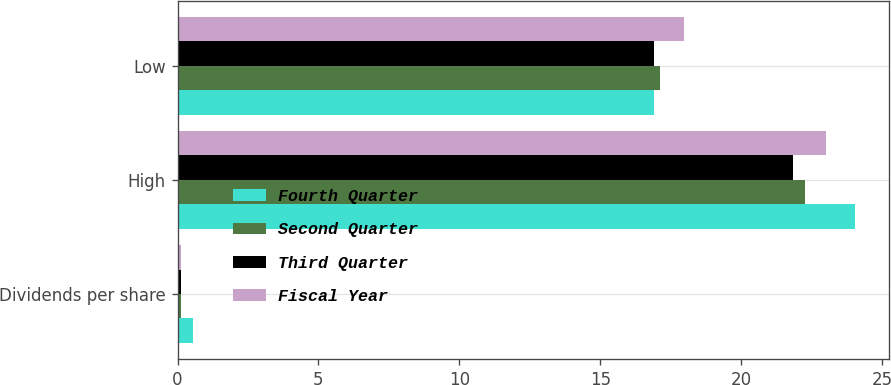<chart> <loc_0><loc_0><loc_500><loc_500><stacked_bar_chart><ecel><fcel>Dividends per share<fcel>High<fcel>Low<nl><fcel>Fourth Quarter<fcel>0.56<fcel>24.02<fcel>16.89<nl><fcel>Second Quarter<fcel>0.14<fcel>22.27<fcel>17.13<nl><fcel>Third Quarter<fcel>0.14<fcel>21.84<fcel>16.89<nl><fcel>Fiscal Year<fcel>0.14<fcel>23<fcel>17.96<nl></chart> 